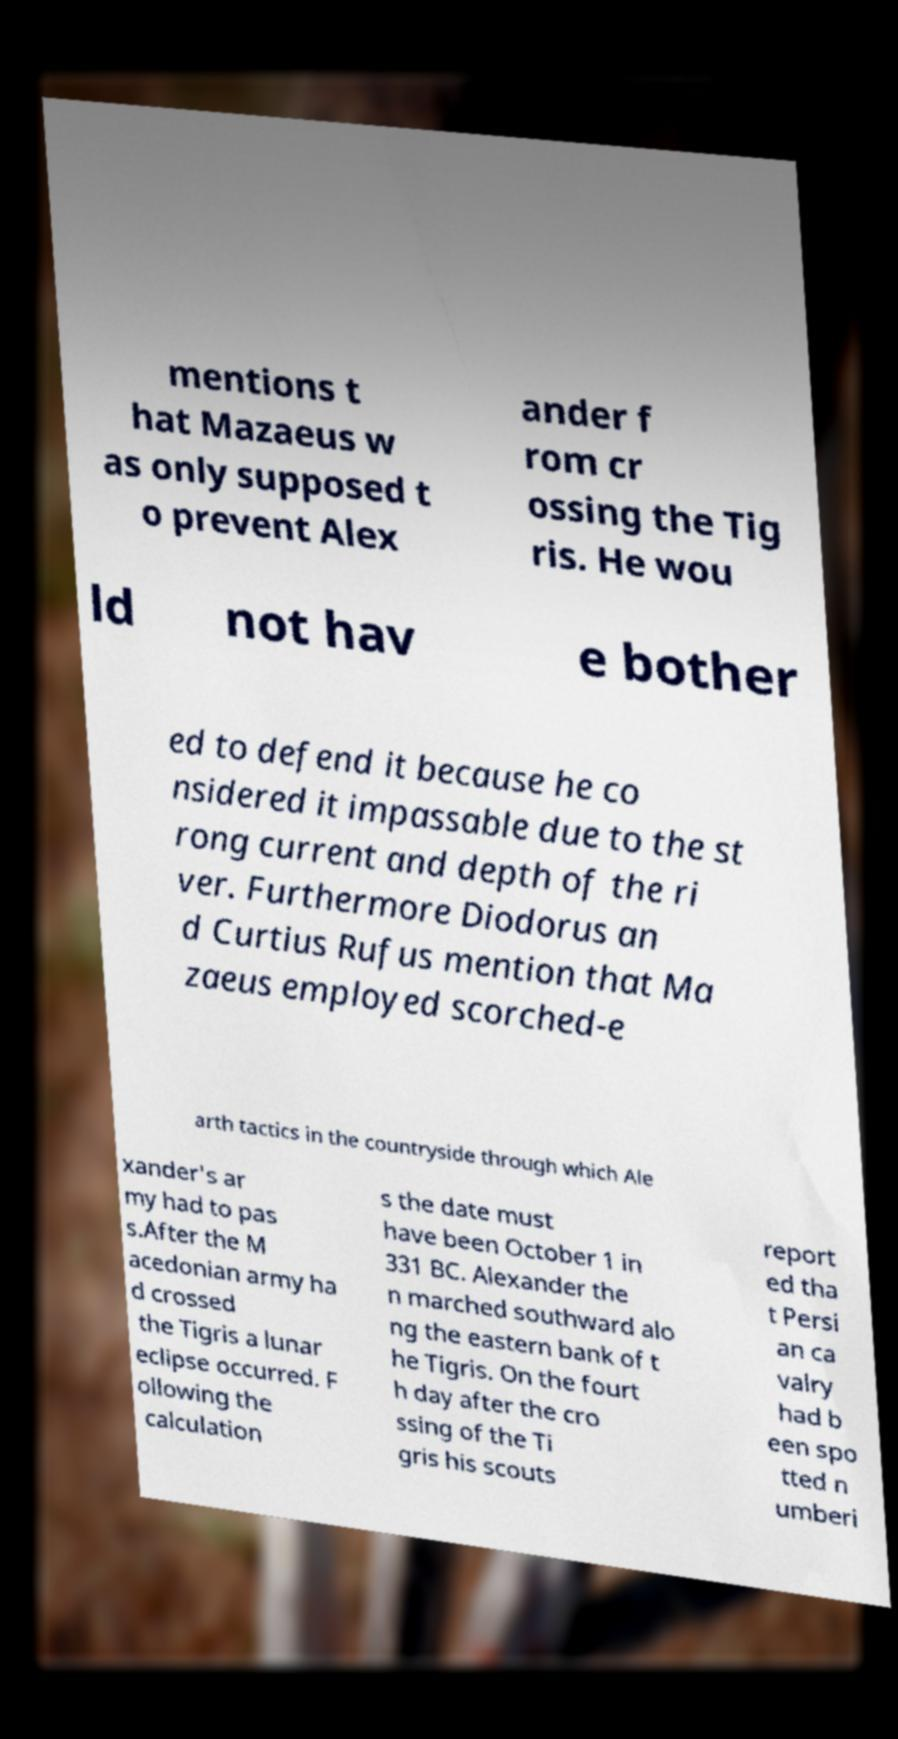For documentation purposes, I need the text within this image transcribed. Could you provide that? mentions t hat Mazaeus w as only supposed t o prevent Alex ander f rom cr ossing the Tig ris. He wou ld not hav e bother ed to defend it because he co nsidered it impassable due to the st rong current and depth of the ri ver. Furthermore Diodorus an d Curtius Rufus mention that Ma zaeus employed scorched-e arth tactics in the countryside through which Ale xander's ar my had to pas s.After the M acedonian army ha d crossed the Tigris a lunar eclipse occurred. F ollowing the calculation s the date must have been October 1 in 331 BC. Alexander the n marched southward alo ng the eastern bank of t he Tigris. On the fourt h day after the cro ssing of the Ti gris his scouts report ed tha t Persi an ca valry had b een spo tted n umberi 